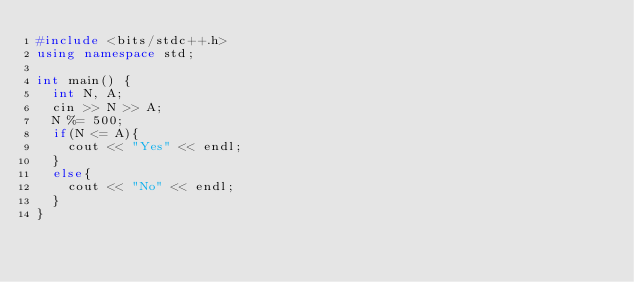Convert code to text. <code><loc_0><loc_0><loc_500><loc_500><_C++_>#include <bits/stdc++.h>
using namespace std;

int main() {
  int N, A;
  cin >> N >> A;
  N %= 500;
  if(N <= A){
    cout << "Yes" << endl;
  }
  else{
    cout << "No" << endl;
  }    
}
</code> 